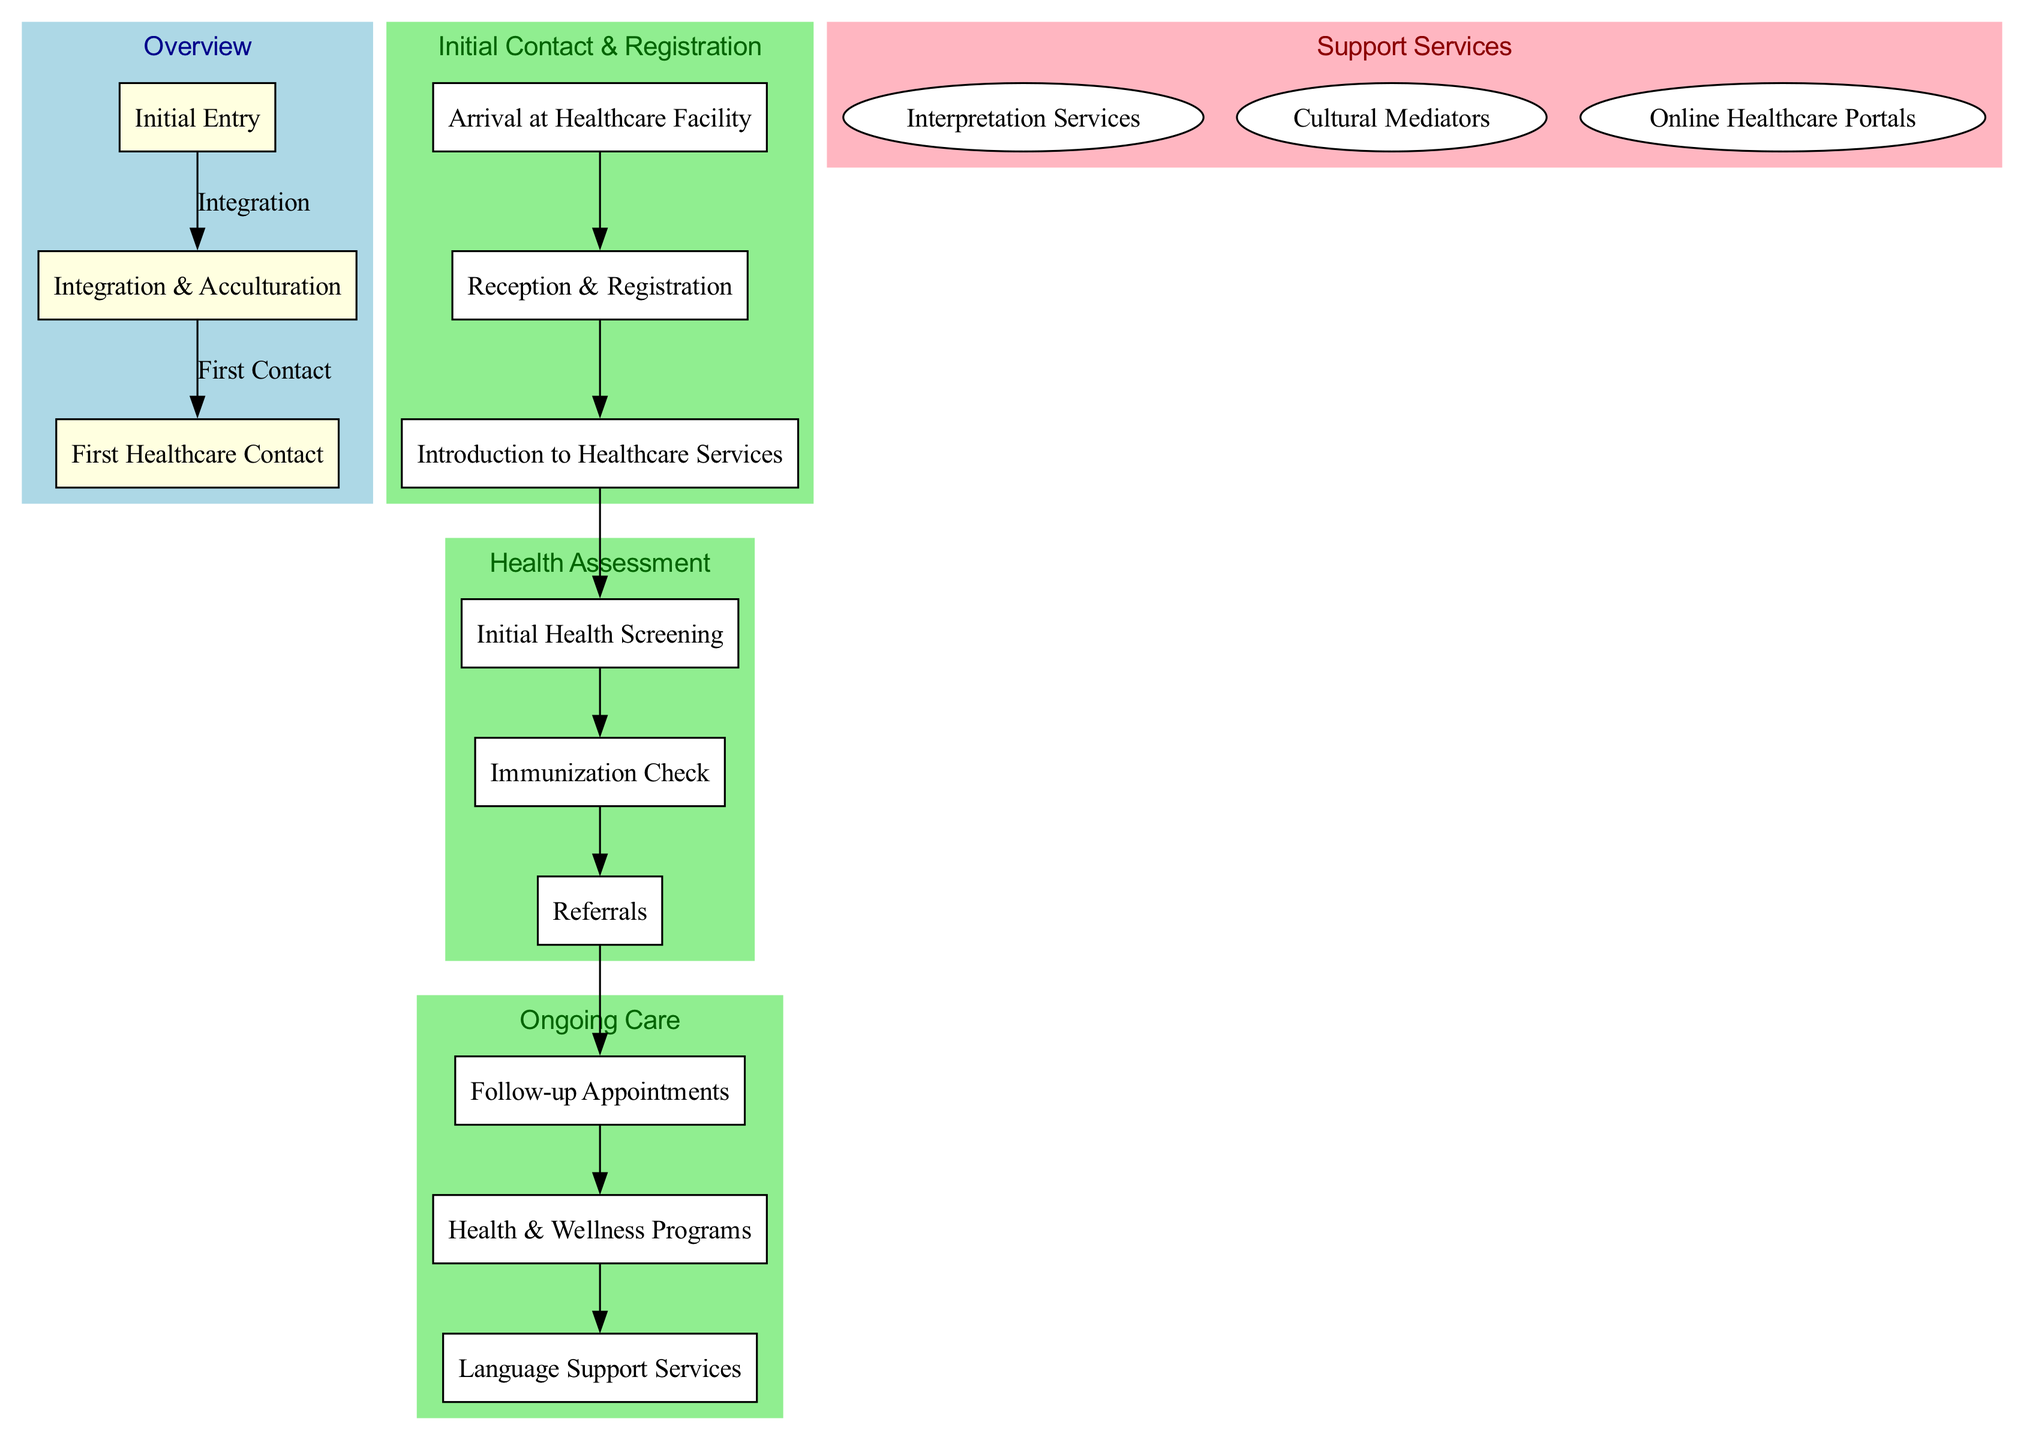What is the first step in the healthcare journey? The diagram indicates that the first step in the healthcare journey is "Arrival at Healthcare Facility." This step is placed within the "Initial Contact & Registration" phase, serving as the starting point for new immigrants seeking healthcare.
Answer: Arrival at Healthcare Facility How many phases are there in the diagram? The diagram illustrates three phases: "Initial Contact & Registration," "Health Assessment," and "Ongoing Care." These phases sequentially outline the immigrant's healthcare journey from registration to continuous health support.
Answer: 3 What services assist non-native speakers? The diagram shows that "Interpretation Services" assist non-native speakers during medical consultations. This service is specifically designed to aid communication between healthcare providers and immigrants who may not speak the local language.
Answer: Interpretation Services Which phase includes immunization checks? The "Health Assessment" phase includes the step "Immunization Check." This step focuses on reviewing and updating an immigrant's immunization records in accordance with local guidelines, highlighting the importance of vaccinations in healthcare access.
Answer: Health Assessment Which step follows the "Reception & Registration"? The step that follows "Reception & Registration" is "Introduction to Healthcare Services." In the flow, this is the next logical step where immigrants are oriented about the available healthcare services after completing their registration.
Answer: Introduction to Healthcare Services How do "Follow-up Appointments" connect to other steps? "Follow-up Appointments" is a step in the "Ongoing Care" phase. It is connected to the previous phase, "Health Assessment," by following after referrals, ensuring that assessed health needs are met through scheduled follow-ups.
Answer: Health Assessment to Ongoing Care connection What type of professionals are cultural mediators? Cultural mediators are professionals available to bridge cultural gaps in healthcare. They play a vital role in helping immigrants understand and navigate the healthcare system, ensuring culturally sensitive care is provided.
Answer: Professionals How many support services are listed in the diagram? There are three support services listed: "Interpretation Services," "Cultural Mediators," and "Online Healthcare Portals." Each service is designed to enhance the healthcare experience for immigrants by improving communication and access to resources.
Answer: 3 